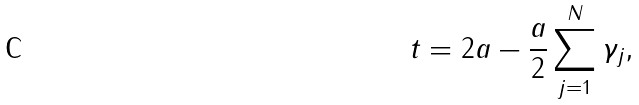Convert formula to latex. <formula><loc_0><loc_0><loc_500><loc_500>t = 2 a - \frac { a } { 2 } \sum _ { j = 1 } ^ { N } \gamma _ { j } ,</formula> 